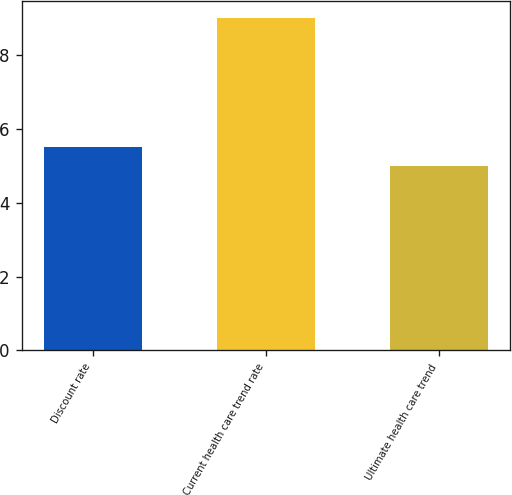Convert chart to OTSL. <chart><loc_0><loc_0><loc_500><loc_500><bar_chart><fcel>Discount rate<fcel>Current health care trend rate<fcel>Ultimate health care trend<nl><fcel>5.5<fcel>9<fcel>5<nl></chart> 